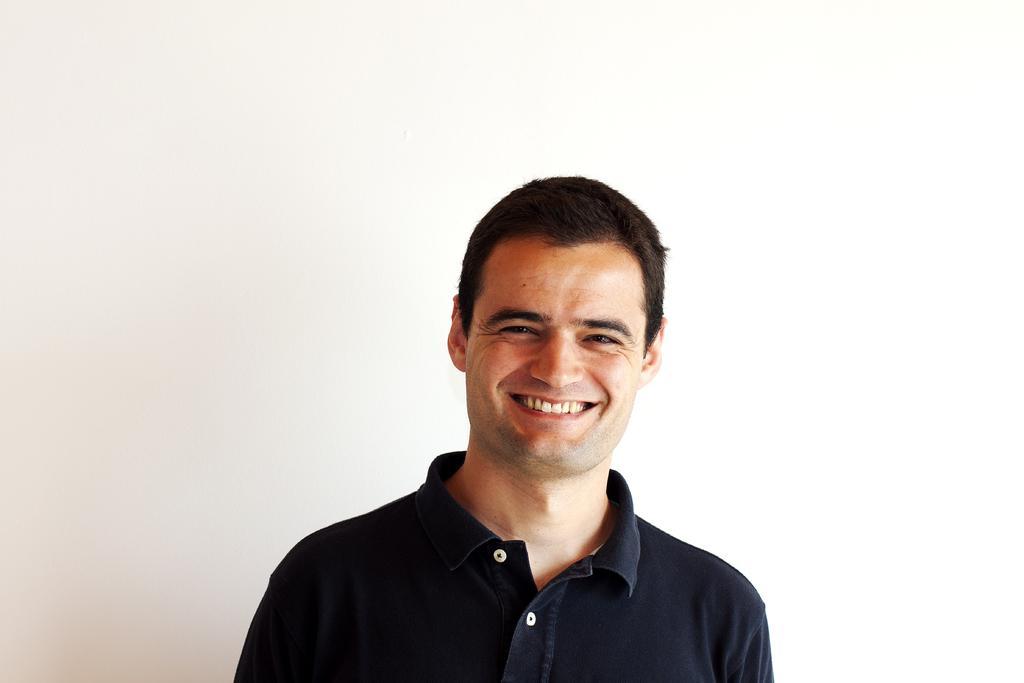Describe this image in one or two sentences. In this image we can see a man smiling. 